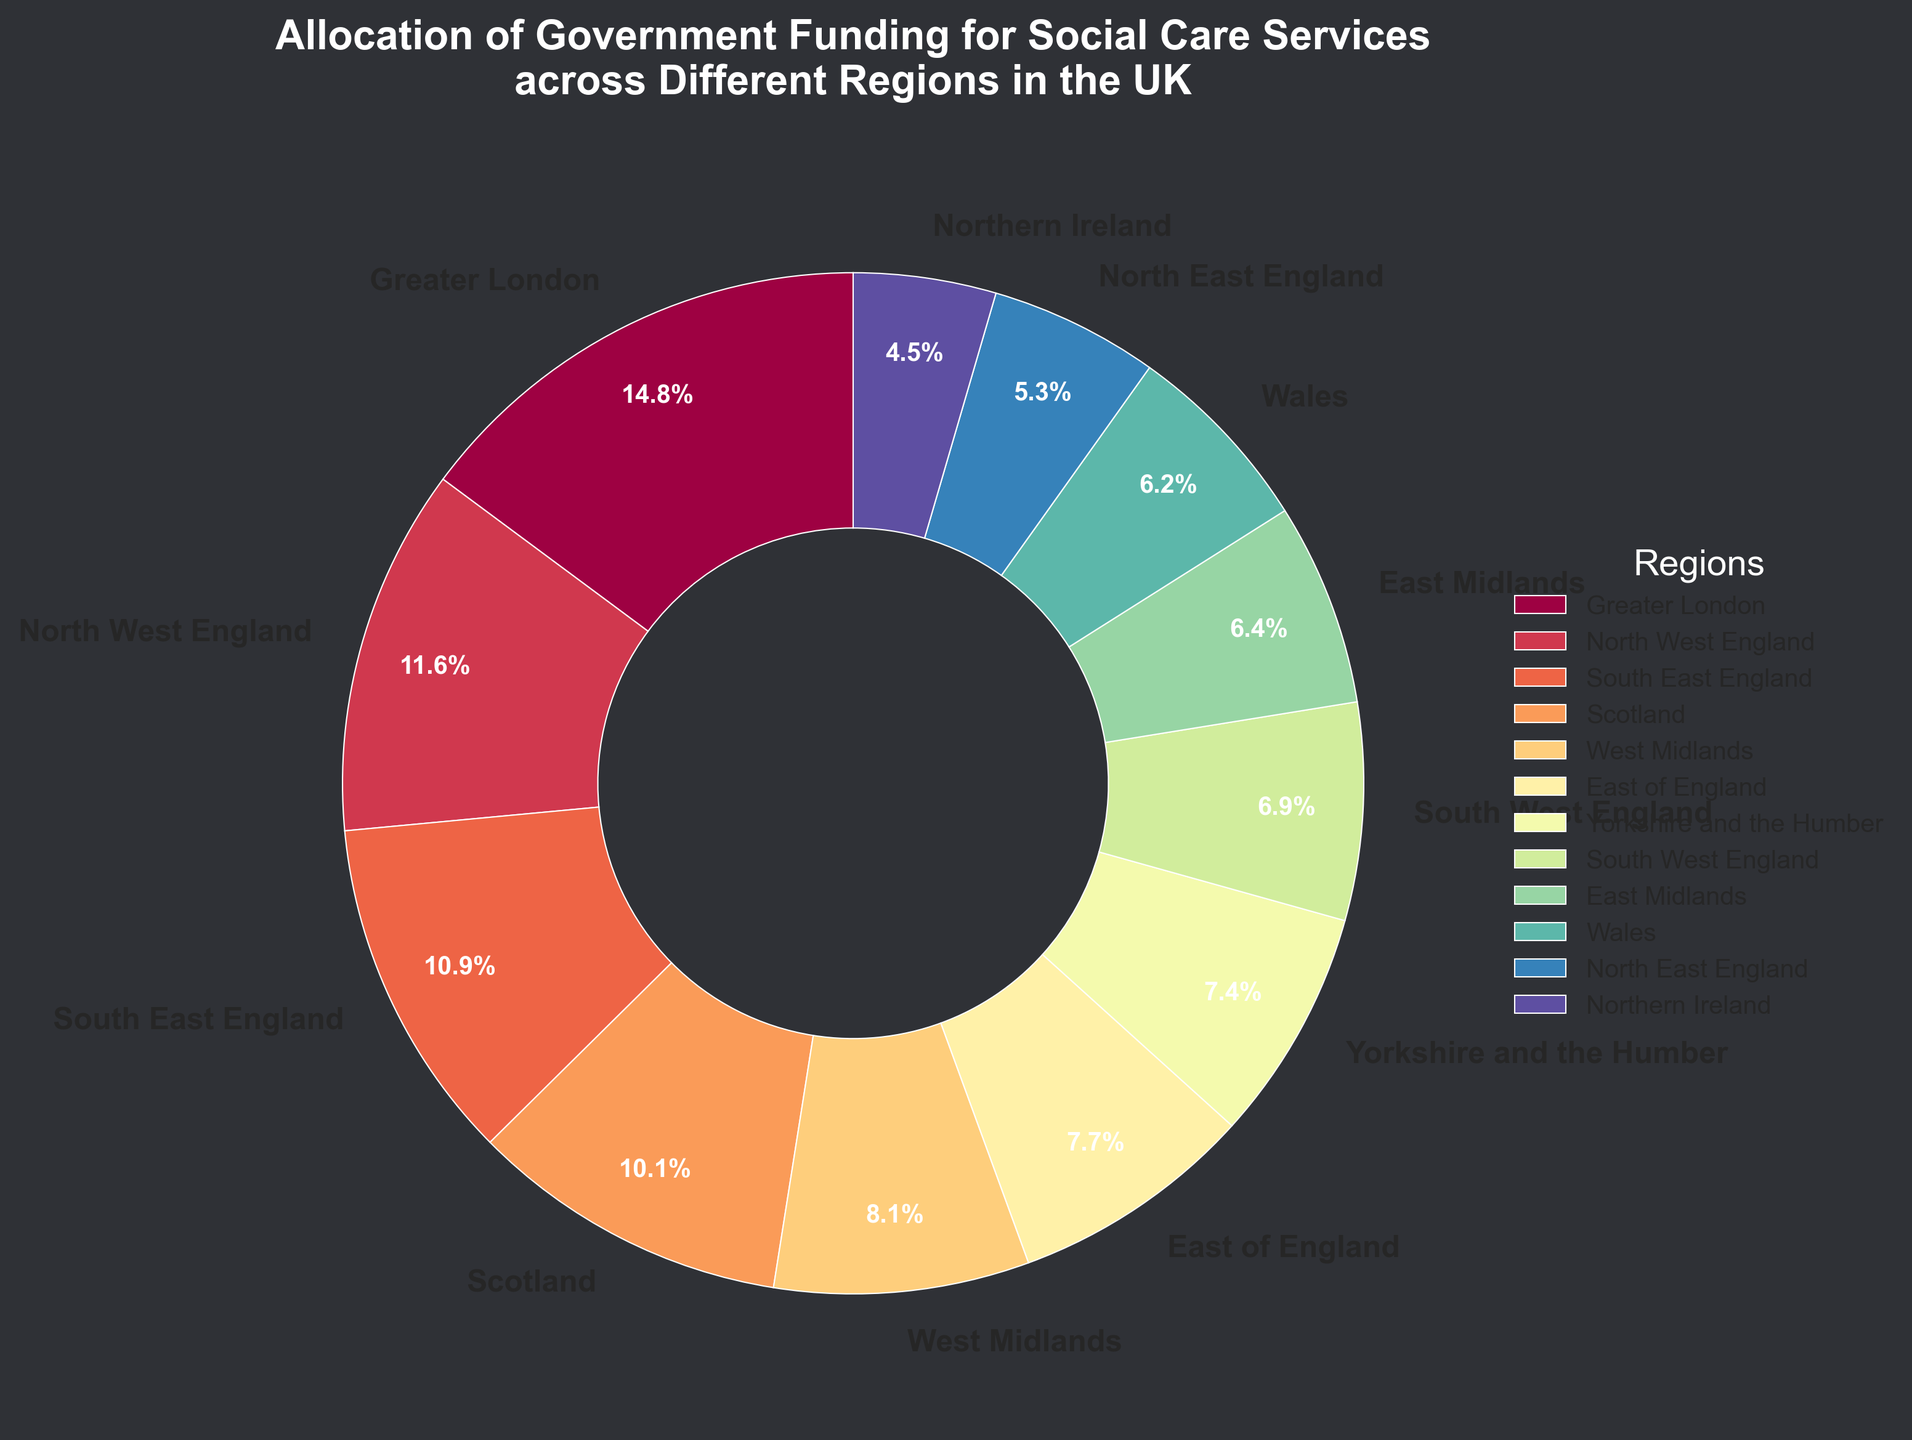What region receives the largest allocation of funding for social care services? The pie chart labels and the described segments show that Greater London has the largest allocation of funding.
Answer: Greater London Which regions receive more funding between North West England and South East England? According to the segment sizes and labels, North West England (£980 million) receives more funding than South East England (£920 million).
Answer: North West England What is the combined percentage of funding allocation for Greater London, North West England, and South East England? Add up the percentages shown on the pie chart for these three regions: Greater London (27.4%), North West England (21.4%), and South East England (20.2%). The combined percentage is 27.4% + 21.4% + 20.2% = 69.0%.
Answer: 69.0% What is the difference in funding allocation between the top-funded region and the least-funded region? The top-funded region is Greater London (£1250 million) and the least-funded region is Northern Ireland (£380 million). Subtract the latter from the former to find the difference: £1250 million - £380 million = £870 million.
Answer: £870 million List the regions that have a funding allocation greater than £600 million. By examining the funding amounts labeled for each region, the regions with more than £600 million allocation are Greater London, North West England, South East England, Scotland, West Midlands, and East of England.
Answer: Greater London, North West England, South East England, Scotland, West Midlands, East of England How does the funding for Wales compare to that of Yorkshire and the Humber? The labels indicate that Wales receives £520 million in funding, while Yorkshire and the Humber receives £620 million. Therefore, Yorkshire and the Humber receives £100 million more than Wales.
Answer: Yorkshire and the Humber How many regions receive funding of less than £500 million? Identify the regions with funding allocations below £500 million by examining the pie chart labels. The regions are North East England and Northern Ireland, making it a total of 2 regions.
Answer: 2 What is the percentage of funding allocation for Scotland relative to the total funding displayed in the pie chart? Scotland’s funding is £850 million. First, calculate the total funding by summing up all regions' allocations: £1250 + £980 + £920 + £850 + £680 + £650 + £620 + £580 + £540 + £520 + £450 + £380 = £8420 million. Then, divide Scotland’s funding by the total and multiply by 100: (850 / 8420) * 100 ≈ 10.1%.
Answer: 10.1% What is the average funding allocation per region? Calculate the total funding: £1250 + £980 + £920 + £850 + £680 + £650 + £620 + £580 + £540 + £520 + £450 + £380 = £8420 million. There are 12 regions, so the average allocation is £8420 million / 12 ≈ £701.67 million.
Answer: £701.67 million Which regions have an equal or greater allocation than the overall average funding allocation per region? The average funding per region is approximately £701.67 million. The regions exceeding this average are Greater London, North West England, South East England, and Scotland.
Answer: Greater London, North West England, South East England, Scotland 